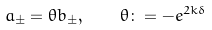Convert formula to latex. <formula><loc_0><loc_0><loc_500><loc_500>a _ { \pm } = \theta b _ { \pm } , \quad \theta \colon = - e ^ { 2 k \delta }</formula> 